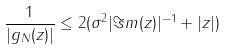<formula> <loc_0><loc_0><loc_500><loc_500>\frac { 1 } { | g _ { N } ( z ) | } \leq 2 ( \sigma ^ { 2 } | \Im m ( z ) | ^ { - 1 } + | z | )</formula> 